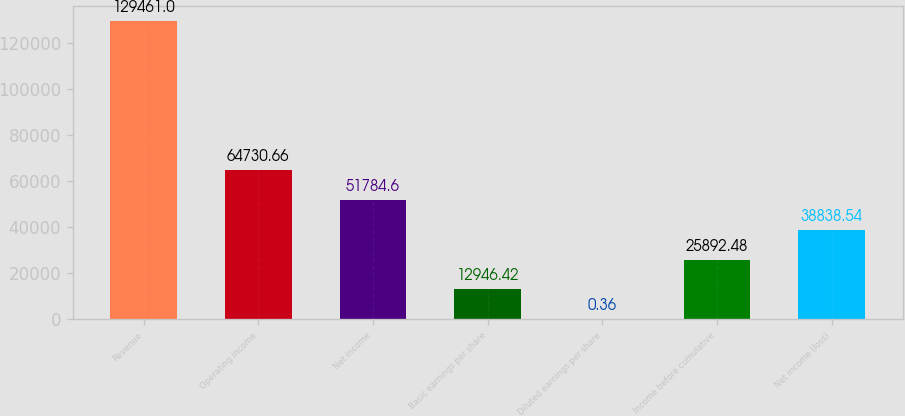Convert chart. <chart><loc_0><loc_0><loc_500><loc_500><bar_chart><fcel>Revenue<fcel>Operating income<fcel>Net income<fcel>Basic earnings per share<fcel>Diluted earnings per share<fcel>Income before cumulative<fcel>Net income (loss)<nl><fcel>129461<fcel>64730.7<fcel>51784.6<fcel>12946.4<fcel>0.36<fcel>25892.5<fcel>38838.5<nl></chart> 